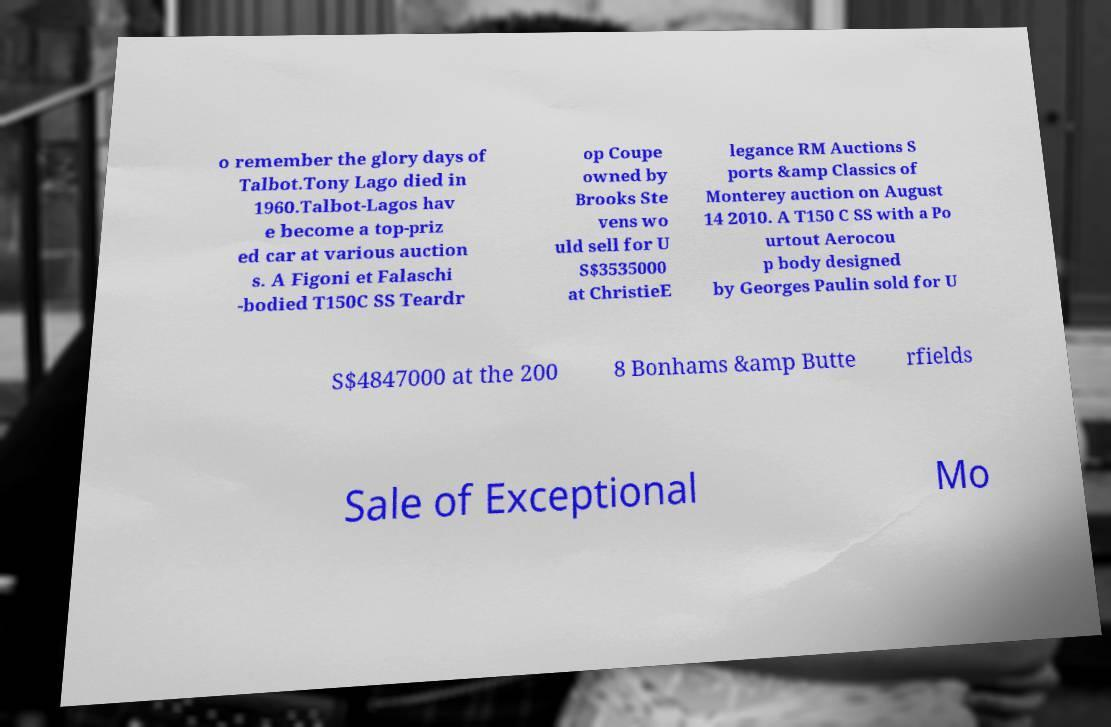For documentation purposes, I need the text within this image transcribed. Could you provide that? o remember the glory days of Talbot.Tony Lago died in 1960.Talbot-Lagos hav e become a top-priz ed car at various auction s. A Figoni et Falaschi -bodied T150C SS Teardr op Coupe owned by Brooks Ste vens wo uld sell for U S$3535000 at ChristieE legance RM Auctions S ports &amp Classics of Monterey auction on August 14 2010. A T150 C SS with a Po urtout Aerocou p body designed by Georges Paulin sold for U S$4847000 at the 200 8 Bonhams &amp Butte rfields Sale of Exceptional Mo 